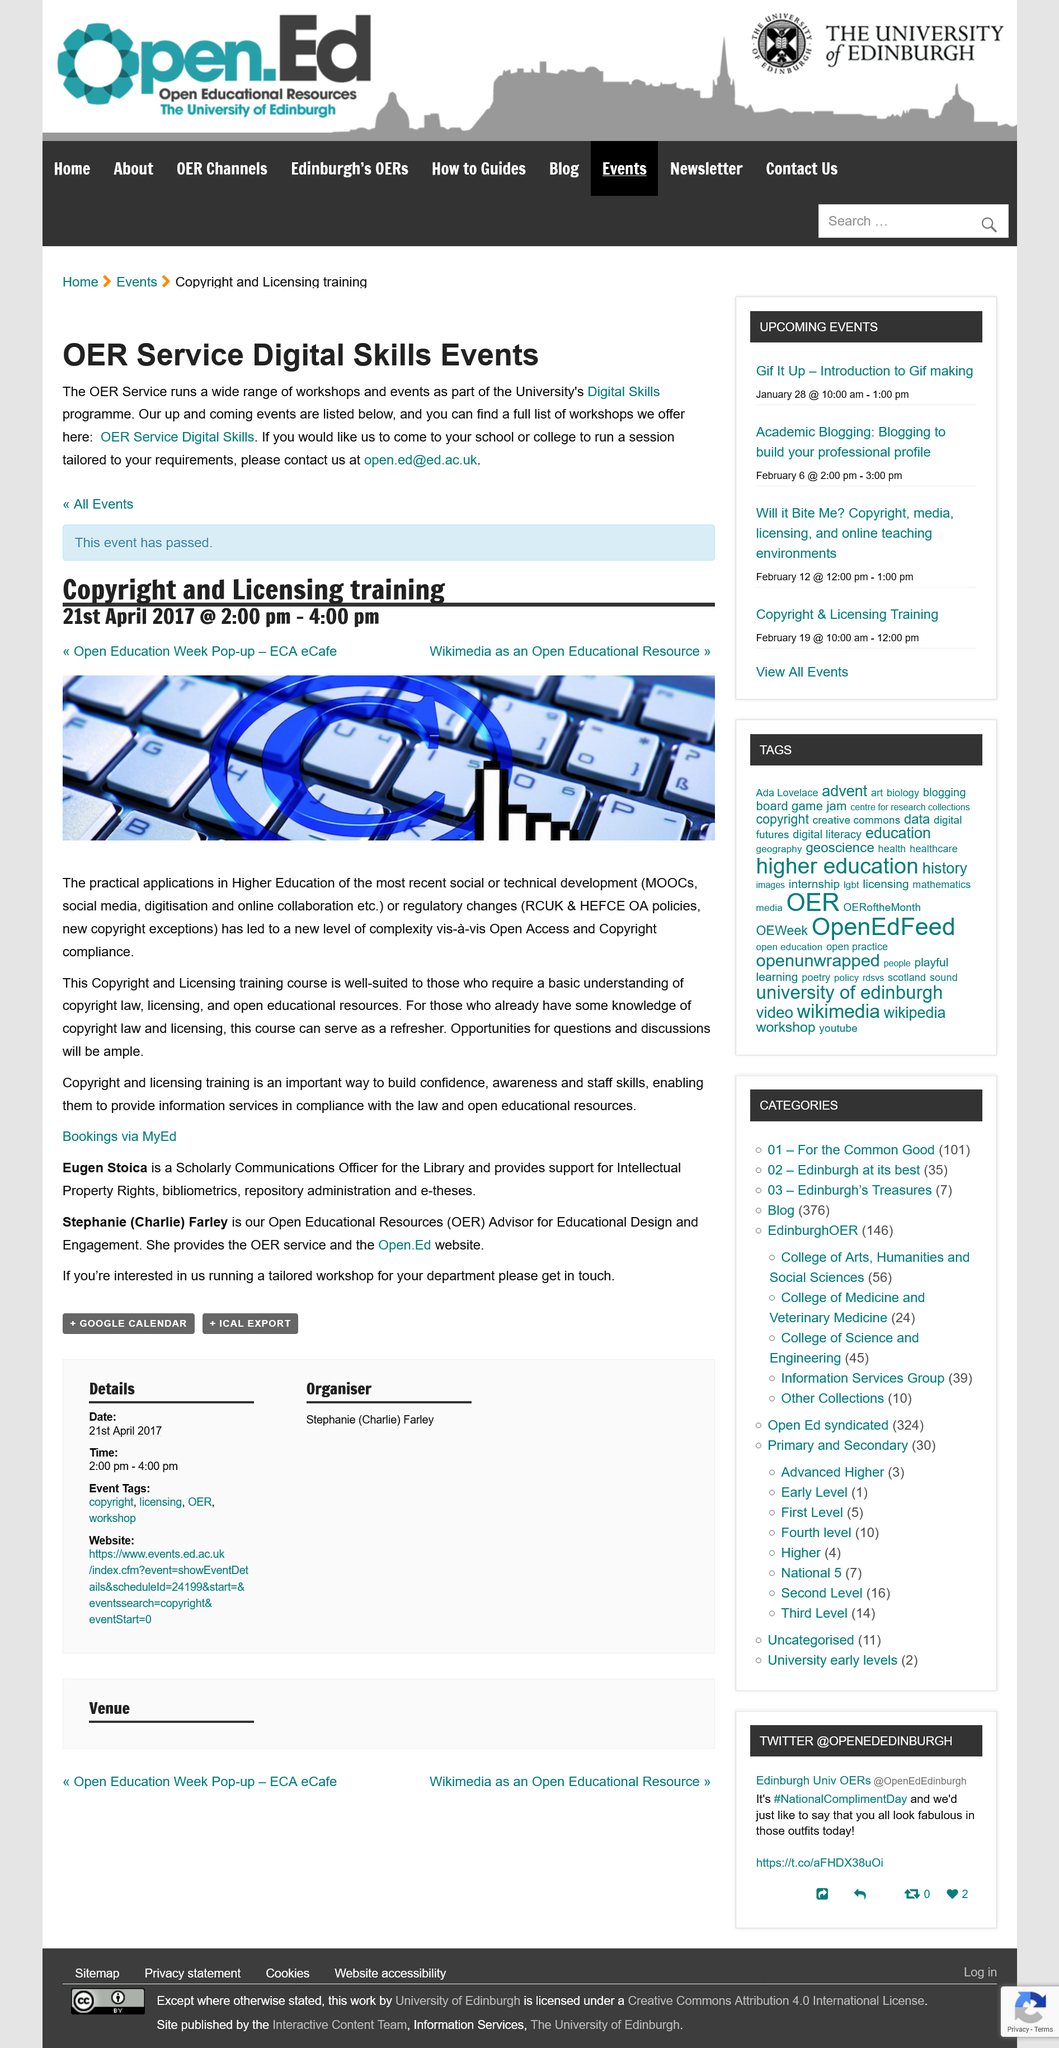Indicate a few pertinent items in this graphic. Copyright and licensing training is crucial in building confidence, increasing awareness, and enhancing staff skills in compliance with the law and open educational resources. Eugen Stoica provides support for intellectual property rights, bibliometrics, repository administration, and e-theses. The event is a 'Copyright and Licensing training' event. The event occurred on April 21st, 2017. The OER service provides a comprehensive range of workshops and events as part of the University's Digital Skills program to cater to the diverse needs of its users. 